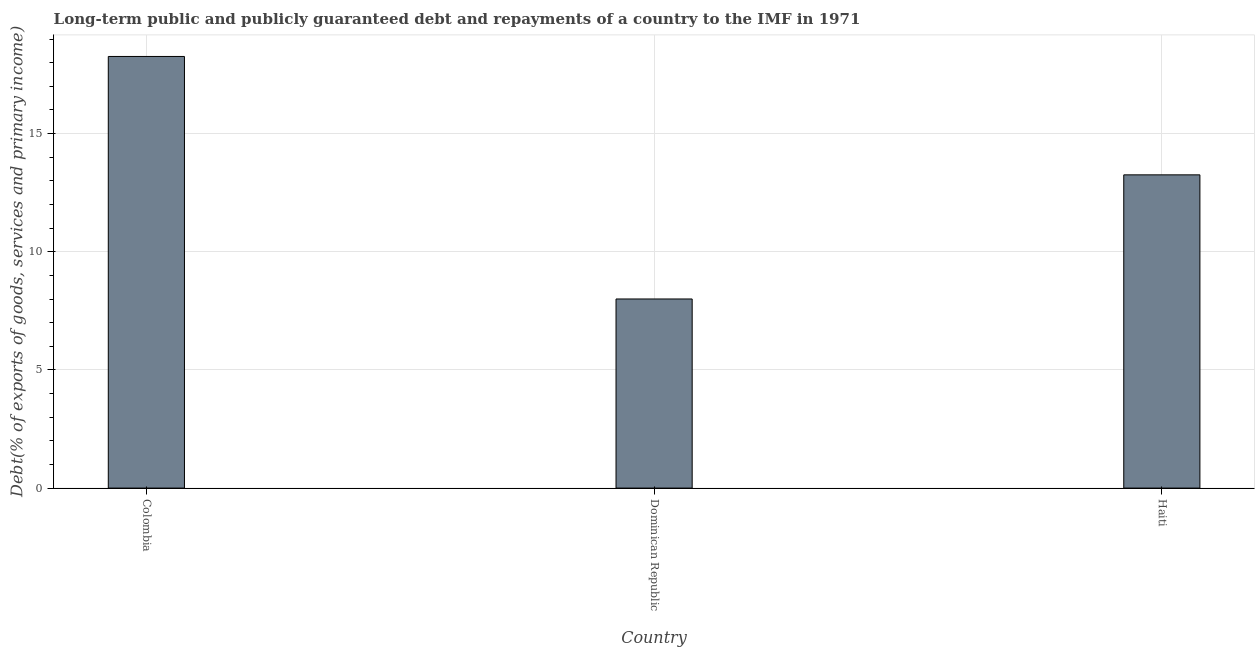Does the graph contain any zero values?
Your answer should be compact. No. Does the graph contain grids?
Ensure brevity in your answer.  Yes. What is the title of the graph?
Offer a terse response. Long-term public and publicly guaranteed debt and repayments of a country to the IMF in 1971. What is the label or title of the X-axis?
Ensure brevity in your answer.  Country. What is the label or title of the Y-axis?
Give a very brief answer. Debt(% of exports of goods, services and primary income). What is the debt service in Dominican Republic?
Your response must be concise. 8. Across all countries, what is the maximum debt service?
Keep it short and to the point. 18.26. Across all countries, what is the minimum debt service?
Provide a succinct answer. 8. In which country was the debt service maximum?
Provide a short and direct response. Colombia. In which country was the debt service minimum?
Give a very brief answer. Dominican Republic. What is the sum of the debt service?
Ensure brevity in your answer.  39.52. What is the difference between the debt service in Dominican Republic and Haiti?
Offer a terse response. -5.25. What is the average debt service per country?
Your answer should be compact. 13.17. What is the median debt service?
Offer a terse response. 13.25. In how many countries, is the debt service greater than 14 %?
Provide a short and direct response. 1. What is the ratio of the debt service in Colombia to that in Dominican Republic?
Your answer should be very brief. 2.28. Is the difference between the debt service in Dominican Republic and Haiti greater than the difference between any two countries?
Offer a very short reply. No. What is the difference between the highest and the second highest debt service?
Give a very brief answer. 5.01. What is the difference between the highest and the lowest debt service?
Provide a short and direct response. 10.26. How many bars are there?
Make the answer very short. 3. Are all the bars in the graph horizontal?
Make the answer very short. No. Are the values on the major ticks of Y-axis written in scientific E-notation?
Ensure brevity in your answer.  No. What is the Debt(% of exports of goods, services and primary income) of Colombia?
Offer a terse response. 18.26. What is the Debt(% of exports of goods, services and primary income) of Dominican Republic?
Make the answer very short. 8. What is the Debt(% of exports of goods, services and primary income) of Haiti?
Make the answer very short. 13.25. What is the difference between the Debt(% of exports of goods, services and primary income) in Colombia and Dominican Republic?
Offer a terse response. 10.26. What is the difference between the Debt(% of exports of goods, services and primary income) in Colombia and Haiti?
Ensure brevity in your answer.  5.01. What is the difference between the Debt(% of exports of goods, services and primary income) in Dominican Republic and Haiti?
Provide a short and direct response. -5.25. What is the ratio of the Debt(% of exports of goods, services and primary income) in Colombia to that in Dominican Republic?
Your response must be concise. 2.28. What is the ratio of the Debt(% of exports of goods, services and primary income) in Colombia to that in Haiti?
Offer a very short reply. 1.38. What is the ratio of the Debt(% of exports of goods, services and primary income) in Dominican Republic to that in Haiti?
Offer a terse response. 0.6. 